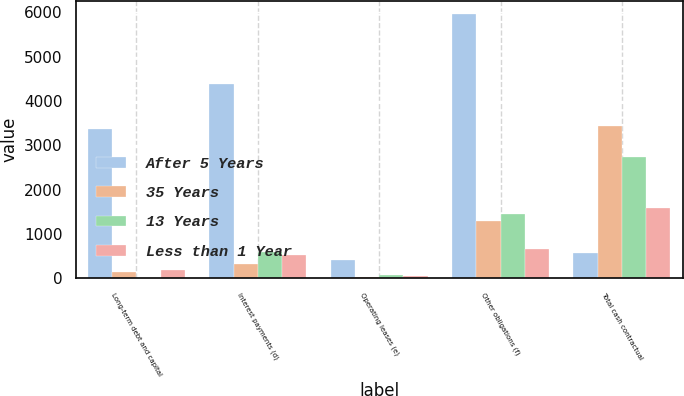<chart> <loc_0><loc_0><loc_500><loc_500><stacked_bar_chart><ecel><fcel>Long-term debt and capital<fcel>Interest payments (d)<fcel>Operating leases (e)<fcel>Other obligations (f)<fcel>Total cash contractual<nl><fcel>After 5 Years<fcel>3366<fcel>4380<fcel>423<fcel>5968<fcel>582<nl><fcel>35 Years<fcel>152<fcel>337<fcel>41<fcel>1300<fcel>3430<nl><fcel>13 Years<fcel>8<fcel>603<fcel>69<fcel>1451<fcel>2733<nl><fcel>Less than 1 Year<fcel>182<fcel>537<fcel>57<fcel>669<fcel>1596<nl></chart> 